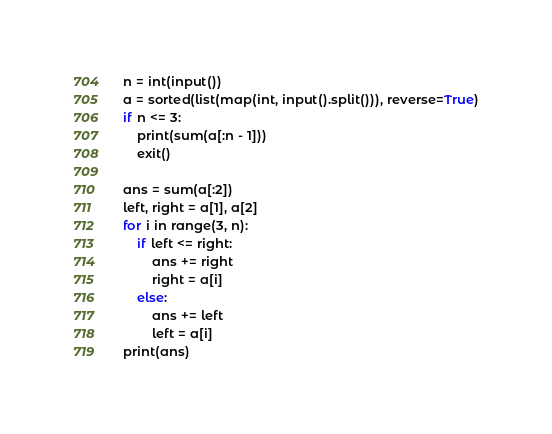Convert code to text. <code><loc_0><loc_0><loc_500><loc_500><_Python_>n = int(input())
a = sorted(list(map(int, input().split())), reverse=True)
if n <= 3:
    print(sum(a[:n - 1]))
    exit()

ans = sum(a[:2])
left, right = a[1], a[2]
for i in range(3, n):
    if left <= right:
        ans += right
        right = a[i]
    else:
        ans += left
        left = a[i]
print(ans)
</code> 